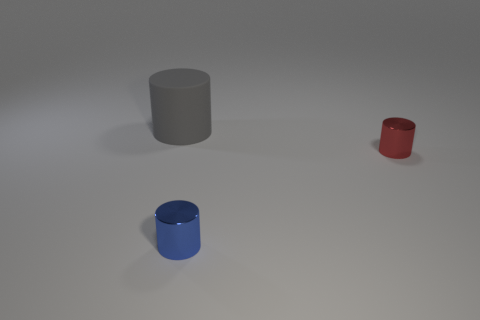Subtract all shiny cylinders. How many cylinders are left? 1 Add 3 blue cylinders. How many objects exist? 6 Subtract all blue cylinders. Subtract all red metal things. How many objects are left? 1 Add 2 small blue things. How many small blue things are left? 3 Add 1 small green shiny cubes. How many small green shiny cubes exist? 1 Subtract 1 red cylinders. How many objects are left? 2 